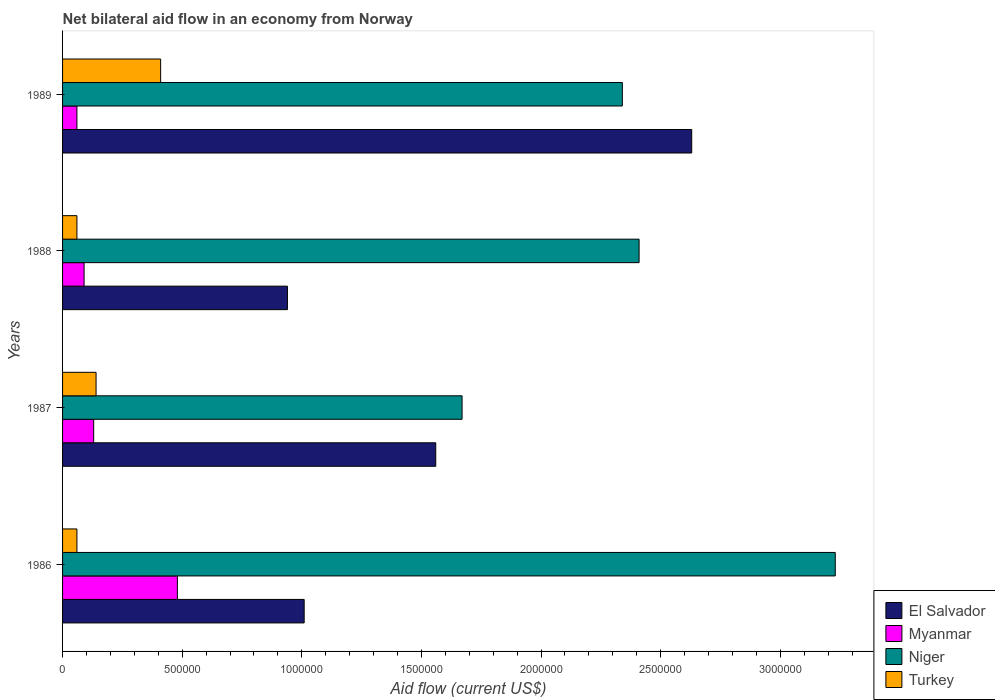How many different coloured bars are there?
Keep it short and to the point. 4. How many groups of bars are there?
Your answer should be very brief. 4. Are the number of bars on each tick of the Y-axis equal?
Provide a succinct answer. Yes. How many bars are there on the 2nd tick from the top?
Ensure brevity in your answer.  4. In how many cases, is the number of bars for a given year not equal to the number of legend labels?
Offer a terse response. 0. What is the net bilateral aid flow in El Salvador in 1987?
Your answer should be very brief. 1.56e+06. Across all years, what is the maximum net bilateral aid flow in Turkey?
Offer a terse response. 4.10e+05. Across all years, what is the minimum net bilateral aid flow in Niger?
Your response must be concise. 1.67e+06. In which year was the net bilateral aid flow in Turkey minimum?
Your answer should be compact. 1986. What is the total net bilateral aid flow in El Salvador in the graph?
Your answer should be very brief. 6.14e+06. What is the difference between the net bilateral aid flow in Myanmar in 1986 and that in 1987?
Your response must be concise. 3.50e+05. What is the difference between the net bilateral aid flow in Turkey in 1987 and the net bilateral aid flow in El Salvador in 1989?
Keep it short and to the point. -2.49e+06. What is the average net bilateral aid flow in Niger per year?
Your response must be concise. 2.41e+06. In the year 1986, what is the difference between the net bilateral aid flow in El Salvador and net bilateral aid flow in Turkey?
Your answer should be very brief. 9.50e+05. In how many years, is the net bilateral aid flow in El Salvador greater than 3100000 US$?
Your answer should be very brief. 0. What is the ratio of the net bilateral aid flow in Myanmar in 1987 to that in 1989?
Offer a very short reply. 2.17. Is the difference between the net bilateral aid flow in El Salvador in 1987 and 1988 greater than the difference between the net bilateral aid flow in Turkey in 1987 and 1988?
Ensure brevity in your answer.  Yes. What is the difference between the highest and the second highest net bilateral aid flow in El Salvador?
Your answer should be very brief. 1.07e+06. What is the difference between the highest and the lowest net bilateral aid flow in Myanmar?
Offer a very short reply. 4.20e+05. Is the sum of the net bilateral aid flow in El Salvador in 1988 and 1989 greater than the maximum net bilateral aid flow in Niger across all years?
Your answer should be compact. Yes. Is it the case that in every year, the sum of the net bilateral aid flow in El Salvador and net bilateral aid flow in Niger is greater than the sum of net bilateral aid flow in Myanmar and net bilateral aid flow in Turkey?
Offer a very short reply. Yes. What does the 3rd bar from the top in 1988 represents?
Your answer should be very brief. Myanmar. Is it the case that in every year, the sum of the net bilateral aid flow in El Salvador and net bilateral aid flow in Myanmar is greater than the net bilateral aid flow in Niger?
Keep it short and to the point. No. Are all the bars in the graph horizontal?
Provide a succinct answer. Yes. What is the difference between two consecutive major ticks on the X-axis?
Keep it short and to the point. 5.00e+05. Are the values on the major ticks of X-axis written in scientific E-notation?
Make the answer very short. No. Does the graph contain grids?
Offer a terse response. No. Where does the legend appear in the graph?
Offer a terse response. Bottom right. How many legend labels are there?
Make the answer very short. 4. How are the legend labels stacked?
Make the answer very short. Vertical. What is the title of the graph?
Your response must be concise. Net bilateral aid flow in an economy from Norway. What is the label or title of the Y-axis?
Your answer should be compact. Years. What is the Aid flow (current US$) in El Salvador in 1986?
Provide a short and direct response. 1.01e+06. What is the Aid flow (current US$) of Myanmar in 1986?
Keep it short and to the point. 4.80e+05. What is the Aid flow (current US$) in Niger in 1986?
Your answer should be very brief. 3.23e+06. What is the Aid flow (current US$) of Turkey in 1986?
Your response must be concise. 6.00e+04. What is the Aid flow (current US$) in El Salvador in 1987?
Your response must be concise. 1.56e+06. What is the Aid flow (current US$) of Myanmar in 1987?
Your answer should be compact. 1.30e+05. What is the Aid flow (current US$) in Niger in 1987?
Ensure brevity in your answer.  1.67e+06. What is the Aid flow (current US$) of El Salvador in 1988?
Your response must be concise. 9.40e+05. What is the Aid flow (current US$) of Myanmar in 1988?
Make the answer very short. 9.00e+04. What is the Aid flow (current US$) in Niger in 1988?
Offer a very short reply. 2.41e+06. What is the Aid flow (current US$) in Turkey in 1988?
Provide a succinct answer. 6.00e+04. What is the Aid flow (current US$) of El Salvador in 1989?
Keep it short and to the point. 2.63e+06. What is the Aid flow (current US$) of Myanmar in 1989?
Your response must be concise. 6.00e+04. What is the Aid flow (current US$) of Niger in 1989?
Provide a succinct answer. 2.34e+06. Across all years, what is the maximum Aid flow (current US$) of El Salvador?
Keep it short and to the point. 2.63e+06. Across all years, what is the maximum Aid flow (current US$) of Niger?
Keep it short and to the point. 3.23e+06. Across all years, what is the minimum Aid flow (current US$) in El Salvador?
Your answer should be very brief. 9.40e+05. Across all years, what is the minimum Aid flow (current US$) of Niger?
Ensure brevity in your answer.  1.67e+06. What is the total Aid flow (current US$) of El Salvador in the graph?
Your answer should be compact. 6.14e+06. What is the total Aid flow (current US$) in Myanmar in the graph?
Provide a short and direct response. 7.60e+05. What is the total Aid flow (current US$) in Niger in the graph?
Offer a terse response. 9.65e+06. What is the total Aid flow (current US$) in Turkey in the graph?
Your response must be concise. 6.70e+05. What is the difference between the Aid flow (current US$) in El Salvador in 1986 and that in 1987?
Your answer should be compact. -5.50e+05. What is the difference between the Aid flow (current US$) of Myanmar in 1986 and that in 1987?
Offer a terse response. 3.50e+05. What is the difference between the Aid flow (current US$) of Niger in 1986 and that in 1987?
Your answer should be very brief. 1.56e+06. What is the difference between the Aid flow (current US$) of Turkey in 1986 and that in 1987?
Keep it short and to the point. -8.00e+04. What is the difference between the Aid flow (current US$) of Myanmar in 1986 and that in 1988?
Your answer should be very brief. 3.90e+05. What is the difference between the Aid flow (current US$) in Niger in 1986 and that in 1988?
Your response must be concise. 8.20e+05. What is the difference between the Aid flow (current US$) of El Salvador in 1986 and that in 1989?
Make the answer very short. -1.62e+06. What is the difference between the Aid flow (current US$) in Niger in 1986 and that in 1989?
Provide a succinct answer. 8.90e+05. What is the difference between the Aid flow (current US$) in Turkey in 1986 and that in 1989?
Provide a succinct answer. -3.50e+05. What is the difference between the Aid flow (current US$) of El Salvador in 1987 and that in 1988?
Make the answer very short. 6.20e+05. What is the difference between the Aid flow (current US$) of Niger in 1987 and that in 1988?
Keep it short and to the point. -7.40e+05. What is the difference between the Aid flow (current US$) in El Salvador in 1987 and that in 1989?
Provide a short and direct response. -1.07e+06. What is the difference between the Aid flow (current US$) of Niger in 1987 and that in 1989?
Make the answer very short. -6.70e+05. What is the difference between the Aid flow (current US$) in El Salvador in 1988 and that in 1989?
Offer a very short reply. -1.69e+06. What is the difference between the Aid flow (current US$) in Myanmar in 1988 and that in 1989?
Your answer should be very brief. 3.00e+04. What is the difference between the Aid flow (current US$) in Turkey in 1988 and that in 1989?
Your response must be concise. -3.50e+05. What is the difference between the Aid flow (current US$) in El Salvador in 1986 and the Aid flow (current US$) in Myanmar in 1987?
Ensure brevity in your answer.  8.80e+05. What is the difference between the Aid flow (current US$) of El Salvador in 1986 and the Aid flow (current US$) of Niger in 1987?
Ensure brevity in your answer.  -6.60e+05. What is the difference between the Aid flow (current US$) in El Salvador in 1986 and the Aid flow (current US$) in Turkey in 1987?
Keep it short and to the point. 8.70e+05. What is the difference between the Aid flow (current US$) in Myanmar in 1986 and the Aid flow (current US$) in Niger in 1987?
Give a very brief answer. -1.19e+06. What is the difference between the Aid flow (current US$) of Niger in 1986 and the Aid flow (current US$) of Turkey in 1987?
Your answer should be very brief. 3.09e+06. What is the difference between the Aid flow (current US$) of El Salvador in 1986 and the Aid flow (current US$) of Myanmar in 1988?
Your answer should be compact. 9.20e+05. What is the difference between the Aid flow (current US$) in El Salvador in 1986 and the Aid flow (current US$) in Niger in 1988?
Make the answer very short. -1.40e+06. What is the difference between the Aid flow (current US$) of El Salvador in 1986 and the Aid flow (current US$) of Turkey in 1988?
Your answer should be very brief. 9.50e+05. What is the difference between the Aid flow (current US$) of Myanmar in 1986 and the Aid flow (current US$) of Niger in 1988?
Provide a short and direct response. -1.93e+06. What is the difference between the Aid flow (current US$) of Myanmar in 1986 and the Aid flow (current US$) of Turkey in 1988?
Offer a very short reply. 4.20e+05. What is the difference between the Aid flow (current US$) in Niger in 1986 and the Aid flow (current US$) in Turkey in 1988?
Offer a very short reply. 3.17e+06. What is the difference between the Aid flow (current US$) of El Salvador in 1986 and the Aid flow (current US$) of Myanmar in 1989?
Offer a very short reply. 9.50e+05. What is the difference between the Aid flow (current US$) of El Salvador in 1986 and the Aid flow (current US$) of Niger in 1989?
Your response must be concise. -1.33e+06. What is the difference between the Aid flow (current US$) of El Salvador in 1986 and the Aid flow (current US$) of Turkey in 1989?
Make the answer very short. 6.00e+05. What is the difference between the Aid flow (current US$) in Myanmar in 1986 and the Aid flow (current US$) in Niger in 1989?
Offer a terse response. -1.86e+06. What is the difference between the Aid flow (current US$) of Niger in 1986 and the Aid flow (current US$) of Turkey in 1989?
Ensure brevity in your answer.  2.82e+06. What is the difference between the Aid flow (current US$) in El Salvador in 1987 and the Aid flow (current US$) in Myanmar in 1988?
Provide a short and direct response. 1.47e+06. What is the difference between the Aid flow (current US$) of El Salvador in 1987 and the Aid flow (current US$) of Niger in 1988?
Your response must be concise. -8.50e+05. What is the difference between the Aid flow (current US$) of El Salvador in 1987 and the Aid flow (current US$) of Turkey in 1988?
Keep it short and to the point. 1.50e+06. What is the difference between the Aid flow (current US$) of Myanmar in 1987 and the Aid flow (current US$) of Niger in 1988?
Offer a very short reply. -2.28e+06. What is the difference between the Aid flow (current US$) of Myanmar in 1987 and the Aid flow (current US$) of Turkey in 1988?
Provide a succinct answer. 7.00e+04. What is the difference between the Aid flow (current US$) of Niger in 1987 and the Aid flow (current US$) of Turkey in 1988?
Give a very brief answer. 1.61e+06. What is the difference between the Aid flow (current US$) in El Salvador in 1987 and the Aid flow (current US$) in Myanmar in 1989?
Provide a short and direct response. 1.50e+06. What is the difference between the Aid flow (current US$) in El Salvador in 1987 and the Aid flow (current US$) in Niger in 1989?
Offer a terse response. -7.80e+05. What is the difference between the Aid flow (current US$) in El Salvador in 1987 and the Aid flow (current US$) in Turkey in 1989?
Offer a very short reply. 1.15e+06. What is the difference between the Aid flow (current US$) of Myanmar in 1987 and the Aid flow (current US$) of Niger in 1989?
Give a very brief answer. -2.21e+06. What is the difference between the Aid flow (current US$) in Myanmar in 1987 and the Aid flow (current US$) in Turkey in 1989?
Your answer should be compact. -2.80e+05. What is the difference between the Aid flow (current US$) in Niger in 1987 and the Aid flow (current US$) in Turkey in 1989?
Ensure brevity in your answer.  1.26e+06. What is the difference between the Aid flow (current US$) of El Salvador in 1988 and the Aid flow (current US$) of Myanmar in 1989?
Ensure brevity in your answer.  8.80e+05. What is the difference between the Aid flow (current US$) in El Salvador in 1988 and the Aid flow (current US$) in Niger in 1989?
Offer a terse response. -1.40e+06. What is the difference between the Aid flow (current US$) of El Salvador in 1988 and the Aid flow (current US$) of Turkey in 1989?
Give a very brief answer. 5.30e+05. What is the difference between the Aid flow (current US$) of Myanmar in 1988 and the Aid flow (current US$) of Niger in 1989?
Give a very brief answer. -2.25e+06. What is the difference between the Aid flow (current US$) in Myanmar in 1988 and the Aid flow (current US$) in Turkey in 1989?
Ensure brevity in your answer.  -3.20e+05. What is the average Aid flow (current US$) in El Salvador per year?
Keep it short and to the point. 1.54e+06. What is the average Aid flow (current US$) in Niger per year?
Your response must be concise. 2.41e+06. What is the average Aid flow (current US$) of Turkey per year?
Provide a short and direct response. 1.68e+05. In the year 1986, what is the difference between the Aid flow (current US$) in El Salvador and Aid flow (current US$) in Myanmar?
Keep it short and to the point. 5.30e+05. In the year 1986, what is the difference between the Aid flow (current US$) of El Salvador and Aid flow (current US$) of Niger?
Your answer should be very brief. -2.22e+06. In the year 1986, what is the difference between the Aid flow (current US$) of El Salvador and Aid flow (current US$) of Turkey?
Keep it short and to the point. 9.50e+05. In the year 1986, what is the difference between the Aid flow (current US$) in Myanmar and Aid flow (current US$) in Niger?
Keep it short and to the point. -2.75e+06. In the year 1986, what is the difference between the Aid flow (current US$) of Myanmar and Aid flow (current US$) of Turkey?
Keep it short and to the point. 4.20e+05. In the year 1986, what is the difference between the Aid flow (current US$) of Niger and Aid flow (current US$) of Turkey?
Offer a terse response. 3.17e+06. In the year 1987, what is the difference between the Aid flow (current US$) of El Salvador and Aid flow (current US$) of Myanmar?
Your response must be concise. 1.43e+06. In the year 1987, what is the difference between the Aid flow (current US$) in El Salvador and Aid flow (current US$) in Turkey?
Ensure brevity in your answer.  1.42e+06. In the year 1987, what is the difference between the Aid flow (current US$) of Myanmar and Aid flow (current US$) of Niger?
Offer a very short reply. -1.54e+06. In the year 1987, what is the difference between the Aid flow (current US$) in Niger and Aid flow (current US$) in Turkey?
Your answer should be compact. 1.53e+06. In the year 1988, what is the difference between the Aid flow (current US$) of El Salvador and Aid flow (current US$) of Myanmar?
Your answer should be very brief. 8.50e+05. In the year 1988, what is the difference between the Aid flow (current US$) in El Salvador and Aid flow (current US$) in Niger?
Your answer should be very brief. -1.47e+06. In the year 1988, what is the difference between the Aid flow (current US$) of El Salvador and Aid flow (current US$) of Turkey?
Give a very brief answer. 8.80e+05. In the year 1988, what is the difference between the Aid flow (current US$) in Myanmar and Aid flow (current US$) in Niger?
Provide a short and direct response. -2.32e+06. In the year 1988, what is the difference between the Aid flow (current US$) of Niger and Aid flow (current US$) of Turkey?
Ensure brevity in your answer.  2.35e+06. In the year 1989, what is the difference between the Aid flow (current US$) in El Salvador and Aid flow (current US$) in Myanmar?
Ensure brevity in your answer.  2.57e+06. In the year 1989, what is the difference between the Aid flow (current US$) of El Salvador and Aid flow (current US$) of Niger?
Your response must be concise. 2.90e+05. In the year 1989, what is the difference between the Aid flow (current US$) of El Salvador and Aid flow (current US$) of Turkey?
Offer a very short reply. 2.22e+06. In the year 1989, what is the difference between the Aid flow (current US$) in Myanmar and Aid flow (current US$) in Niger?
Offer a terse response. -2.28e+06. In the year 1989, what is the difference between the Aid flow (current US$) in Myanmar and Aid flow (current US$) in Turkey?
Ensure brevity in your answer.  -3.50e+05. In the year 1989, what is the difference between the Aid flow (current US$) of Niger and Aid flow (current US$) of Turkey?
Your answer should be compact. 1.93e+06. What is the ratio of the Aid flow (current US$) of El Salvador in 1986 to that in 1987?
Your answer should be compact. 0.65. What is the ratio of the Aid flow (current US$) in Myanmar in 1986 to that in 1987?
Provide a succinct answer. 3.69. What is the ratio of the Aid flow (current US$) in Niger in 1986 to that in 1987?
Keep it short and to the point. 1.93. What is the ratio of the Aid flow (current US$) of Turkey in 1986 to that in 1987?
Ensure brevity in your answer.  0.43. What is the ratio of the Aid flow (current US$) of El Salvador in 1986 to that in 1988?
Ensure brevity in your answer.  1.07. What is the ratio of the Aid flow (current US$) of Myanmar in 1986 to that in 1988?
Your response must be concise. 5.33. What is the ratio of the Aid flow (current US$) in Niger in 1986 to that in 1988?
Offer a terse response. 1.34. What is the ratio of the Aid flow (current US$) in Turkey in 1986 to that in 1988?
Your answer should be compact. 1. What is the ratio of the Aid flow (current US$) of El Salvador in 1986 to that in 1989?
Make the answer very short. 0.38. What is the ratio of the Aid flow (current US$) of Niger in 1986 to that in 1989?
Offer a very short reply. 1.38. What is the ratio of the Aid flow (current US$) in Turkey in 1986 to that in 1989?
Provide a short and direct response. 0.15. What is the ratio of the Aid flow (current US$) of El Salvador in 1987 to that in 1988?
Your response must be concise. 1.66. What is the ratio of the Aid flow (current US$) of Myanmar in 1987 to that in 1988?
Give a very brief answer. 1.44. What is the ratio of the Aid flow (current US$) in Niger in 1987 to that in 1988?
Make the answer very short. 0.69. What is the ratio of the Aid flow (current US$) in Turkey in 1987 to that in 1988?
Provide a short and direct response. 2.33. What is the ratio of the Aid flow (current US$) of El Salvador in 1987 to that in 1989?
Your response must be concise. 0.59. What is the ratio of the Aid flow (current US$) in Myanmar in 1987 to that in 1989?
Ensure brevity in your answer.  2.17. What is the ratio of the Aid flow (current US$) of Niger in 1987 to that in 1989?
Provide a succinct answer. 0.71. What is the ratio of the Aid flow (current US$) in Turkey in 1987 to that in 1989?
Give a very brief answer. 0.34. What is the ratio of the Aid flow (current US$) of El Salvador in 1988 to that in 1989?
Offer a terse response. 0.36. What is the ratio of the Aid flow (current US$) in Myanmar in 1988 to that in 1989?
Your answer should be compact. 1.5. What is the ratio of the Aid flow (current US$) in Niger in 1988 to that in 1989?
Offer a very short reply. 1.03. What is the ratio of the Aid flow (current US$) of Turkey in 1988 to that in 1989?
Your answer should be very brief. 0.15. What is the difference between the highest and the second highest Aid flow (current US$) of El Salvador?
Offer a terse response. 1.07e+06. What is the difference between the highest and the second highest Aid flow (current US$) in Niger?
Your answer should be compact. 8.20e+05. What is the difference between the highest and the lowest Aid flow (current US$) of El Salvador?
Make the answer very short. 1.69e+06. What is the difference between the highest and the lowest Aid flow (current US$) in Myanmar?
Provide a succinct answer. 4.20e+05. What is the difference between the highest and the lowest Aid flow (current US$) in Niger?
Give a very brief answer. 1.56e+06. What is the difference between the highest and the lowest Aid flow (current US$) of Turkey?
Ensure brevity in your answer.  3.50e+05. 